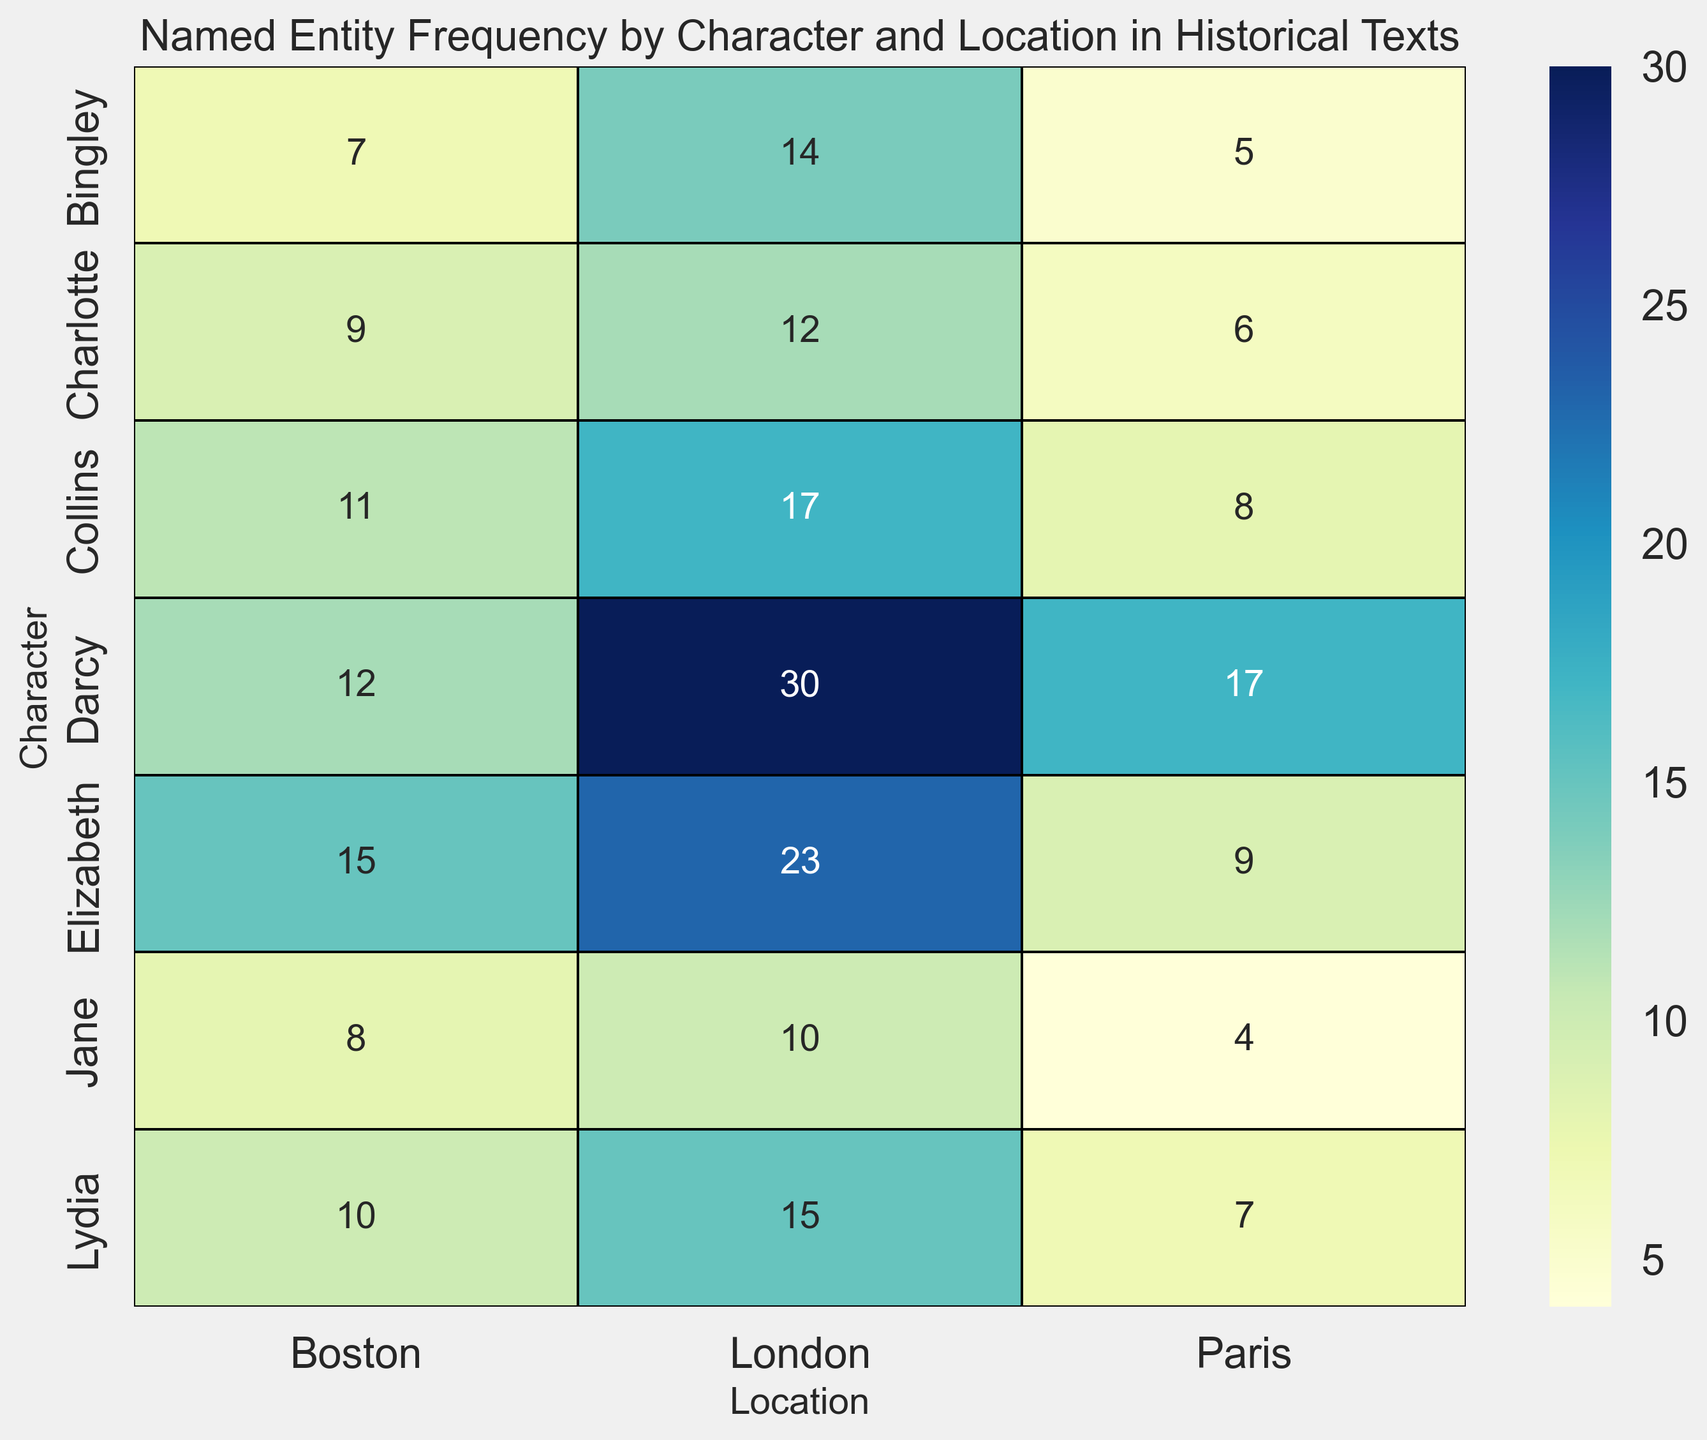What is the most frequent named entity for each location? To answer this, we check the highest frequency in each column (location) of the heatmap. For Boston, Elizabeth has 15; for Paris, Darcy has 17; and for London, Darcy has 30.
Answer: Elizabeth (Boston), Darcy (Paris), Darcy (London) Which character has the smallest total frequency across all locations? Sum the frequencies across all locations for each character: Elizabeth (47), Darcy (59), Jane (22), Bingley (26), Charlotte (27), Collins (36), Lydia (32). The smallest sum is for Jane.
Answer: Jane What is the total frequency of named entities in each location? Sum the values for each row in each column (location): Boston = 15 + 12 + 8 + 7 + 9 + 11 + 10 = 72, Paris = 9 + 17 + 4 + 5 + 6 + 8 + 7 = 56, London = 23 + 30 + 10 + 14 + 12 + 17 + 15 = 121.
Answer: Boston (72), Paris (56), London (121) Which location has the highest average named entity frequency per character? Compute the average frequency per character for each location: Boston (72/7 ≈ 10.3), Paris (56/7 ≈ 8), London (121/7 ≈ 17.3). London has the highest average.
Answer: London Which characters have a frequency greater than 10 in any location? Check for any cell in each character's row that is greater than 10: Elizabeth (Boston 15, London 23), Darcy (Boston 12, Paris 17, London 30), Collins (Boston 11, London 17), Lydia (London 15).
Answer: Elizabeth, Darcy, Collins, Lydia What is the frequency difference between Elizabeth in London and Jane in Paris? Subtract the frequency of Jane in Paris (4) from Elizabeth in London (23).
Answer: 19 Is there any character that has a uniform frequency across all locations? Examine each character's row to see if the frequency is the same in all cells: No character has a uniform frequency in Boston, Paris, and London.
Answer: No How many characters have their highest frequency in London? Compare the highest frequency for each character across all locations to see if it's in London: Elizabeth (23), Darcy (30), Jane (10), Bingley (14), Charlotte (12), Collins (17), Lydia (15) — all have their highest frequencies in London.
Answer: 7 